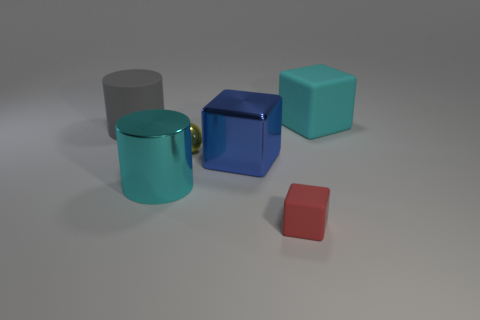Is the color of the big metallic cylinder the same as the big rubber cube?
Your response must be concise. Yes. There is a thing that is the same color as the large rubber block; what material is it?
Offer a terse response. Metal. How many cubes have the same material as the ball?
Offer a terse response. 1. The big cylinder that is made of the same material as the tiny sphere is what color?
Offer a terse response. Cyan. What is the shape of the small yellow metallic object?
Your response must be concise. Sphere. There is a cylinder in front of the large blue shiny object; what is its material?
Offer a very short reply. Metal. Are there any rubber things of the same color as the big metallic cylinder?
Make the answer very short. Yes. What is the shape of the red matte thing that is the same size as the yellow sphere?
Give a very brief answer. Cube. There is a matte object in front of the cyan shiny cylinder; what color is it?
Ensure brevity in your answer.  Red. There is a large cyan object that is in front of the big gray thing; are there any red rubber things that are behind it?
Provide a short and direct response. No. 